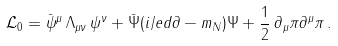Convert formula to latex. <formula><loc_0><loc_0><loc_500><loc_500>\mathcal { L } _ { 0 } = \bar { \psi } ^ { \mu } \, \Lambda _ { \mu \nu } \, \psi ^ { \nu } + \bar { \Psi } ( i \slash e d { \partial } - m _ { N } ) \Psi + \frac { 1 } { 2 } \, \partial _ { \mu } \pi \partial ^ { \mu } \pi \, .</formula> 